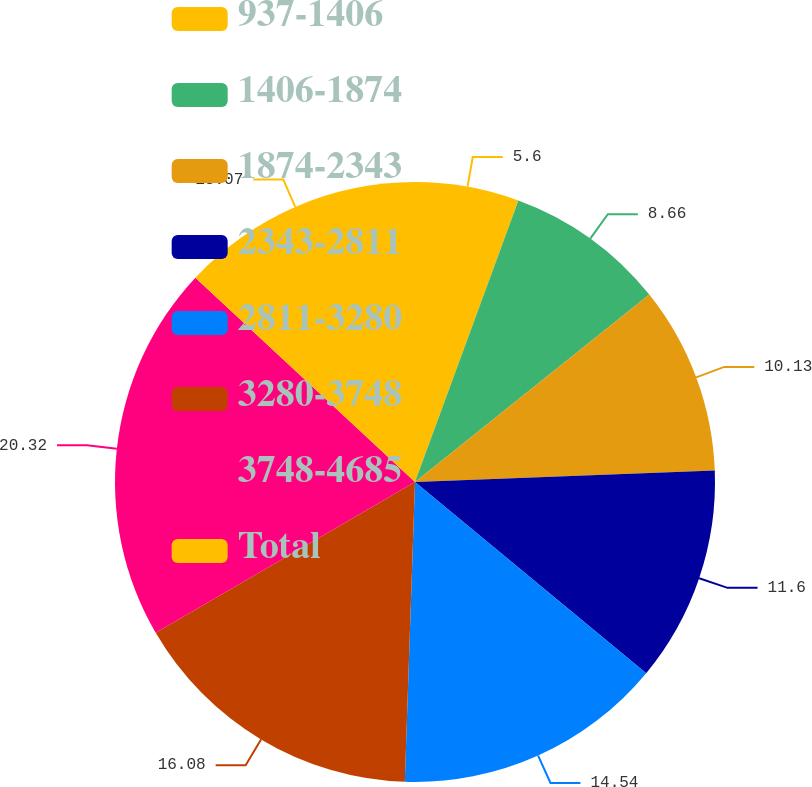<chart> <loc_0><loc_0><loc_500><loc_500><pie_chart><fcel>937-1406<fcel>1406-1874<fcel>1874-2343<fcel>2343-2811<fcel>2811-3280<fcel>3280-3748<fcel>3748-4685<fcel>Total<nl><fcel>5.6%<fcel>8.66%<fcel>10.13%<fcel>11.6%<fcel>14.54%<fcel>16.07%<fcel>20.31%<fcel>13.07%<nl></chart> 